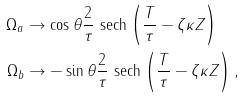Convert formula to latex. <formula><loc_0><loc_0><loc_500><loc_500>\Omega _ { a } & \to \cos \theta \frac { 2 } { \tau } \text { sech} \left ( \frac { T } { \tau } - \zeta \kappa Z \right ) \\ \Omega _ { b } & \to - \sin \theta \frac { 2 } { \tau } \text { sech} \left ( \frac { T } { \tau } - \zeta \kappa Z \right ) ,</formula> 